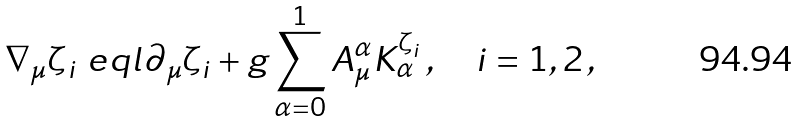Convert formula to latex. <formula><loc_0><loc_0><loc_500><loc_500>\nabla _ { \mu } \zeta _ { i } \ e q l \partial _ { \mu } \zeta _ { i } + g \sum _ { \alpha = 0 } ^ { 1 } A _ { \mu } ^ { \alpha } K _ { \alpha } ^ { \zeta _ { i } } \, , \quad i = 1 , 2 \, ,</formula> 